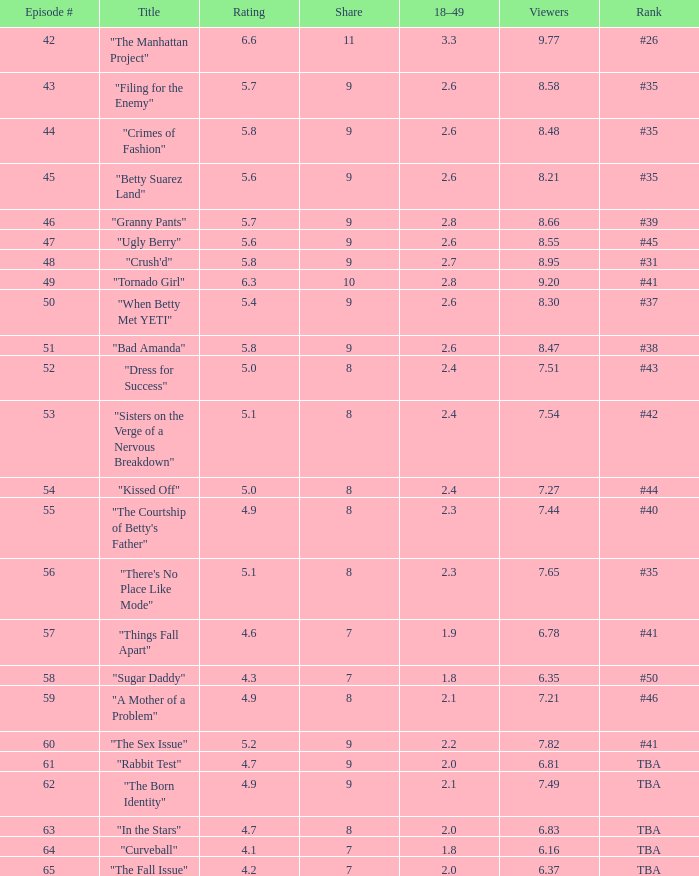For an episode titled "curveball" with a number above 58 and a rating under 4.1, what is the lowest viewer count? None. 